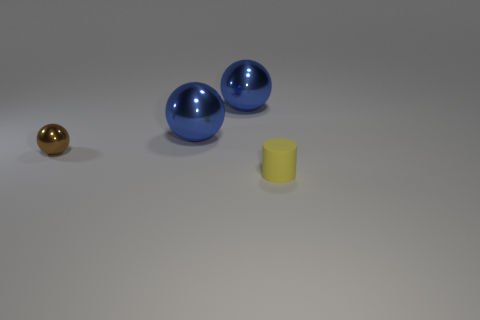How many cylinders are big purple matte things or large blue things?
Provide a short and direct response. 0. How many things are brown metal balls or balls behind the brown metal sphere?
Your response must be concise. 3. Are there any tiny balls?
Make the answer very short. Yes. How many tiny objects have the same color as the small rubber cylinder?
Make the answer very short. 0. What size is the thing that is in front of the tiny thing on the left side of the matte cylinder?
Ensure brevity in your answer.  Small. Is there another big ball made of the same material as the brown sphere?
Your response must be concise. Yes. There is a object that is the same size as the brown shiny sphere; what material is it?
Give a very brief answer. Rubber. There is a tiny object that is right of the tiny sphere; does it have the same color as the tiny object to the left of the small yellow matte cylinder?
Provide a succinct answer. No. There is a small thing that is right of the tiny brown metallic sphere; are there any big objects that are in front of it?
Give a very brief answer. No. Is the shape of the tiny thing on the left side of the cylinder the same as the thing in front of the brown ball?
Your answer should be compact. No. 